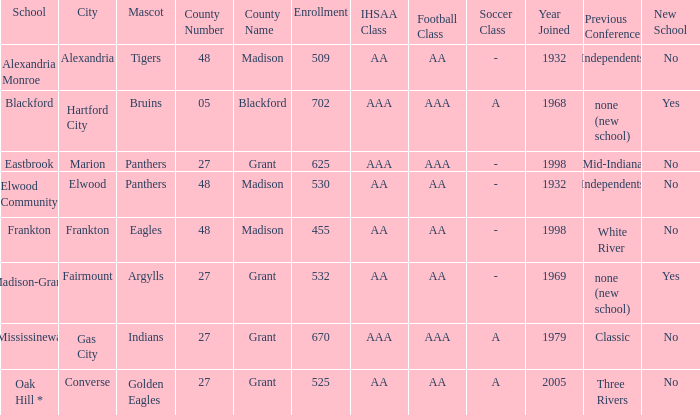What is the school with the location of alexandria? Alexandria Monroe. 